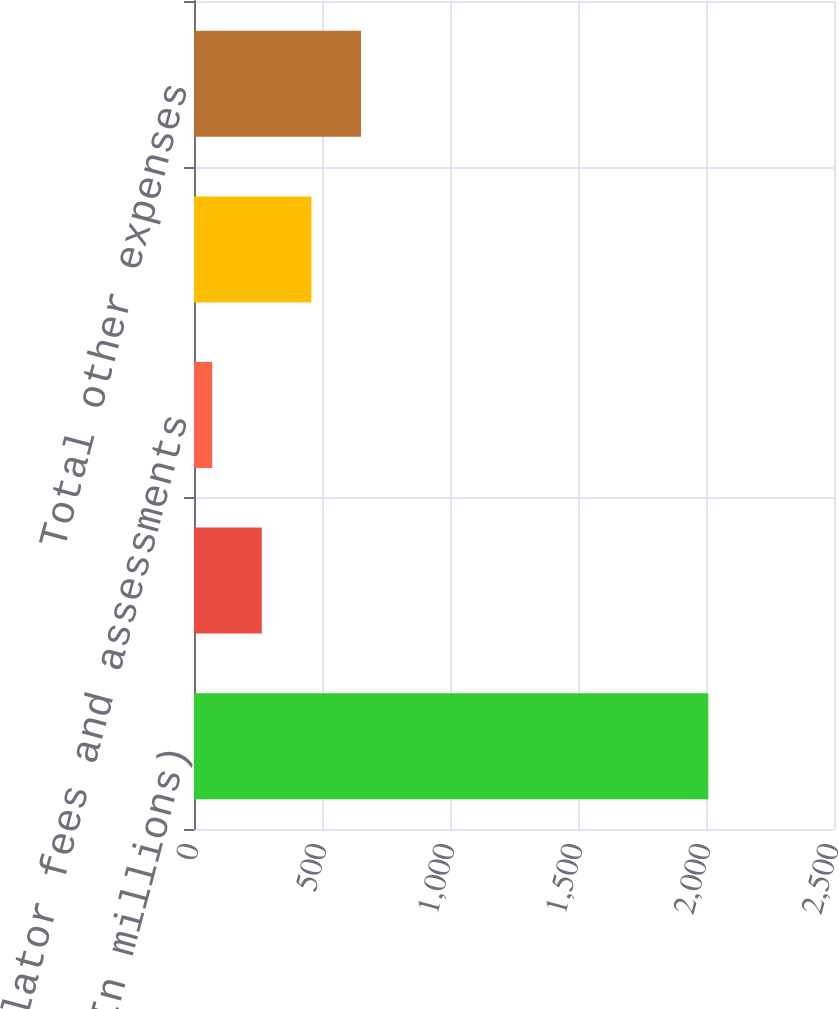<chart> <loc_0><loc_0><loc_500><loc_500><bar_chart><fcel>(In millions)<fcel>Securities processing<fcel>Regulator fees and assessments<fcel>Other<fcel>Total other expenses<nl><fcel>2009<fcel>264.8<fcel>71<fcel>458.6<fcel>652.4<nl></chart> 